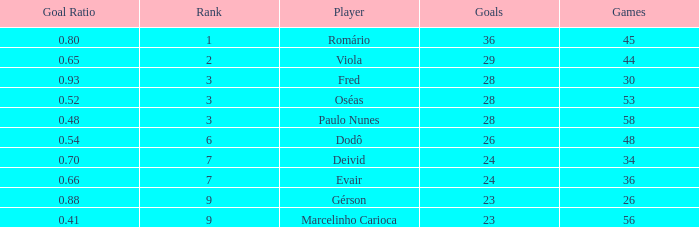How many goal ratios have rank of 2 with more than 44 games? 0.0. 